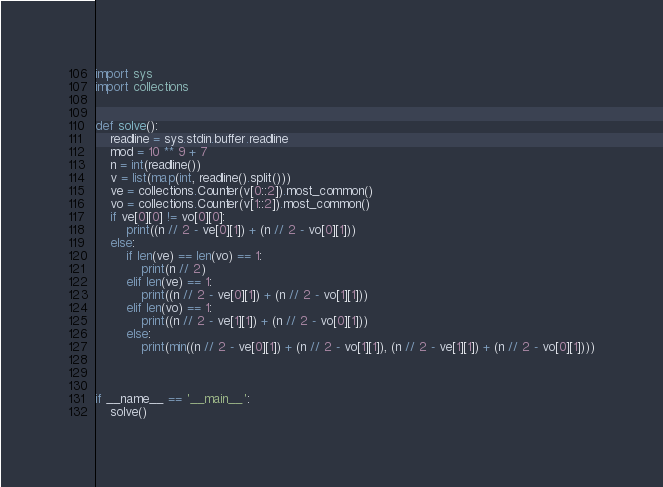<code> <loc_0><loc_0><loc_500><loc_500><_Python_>import sys
import collections


def solve():
    readline = sys.stdin.buffer.readline
    mod = 10 ** 9 + 7
    n = int(readline())
    v = list(map(int, readline().split()))
    ve = collections.Counter(v[0::2]).most_common()
    vo = collections.Counter(v[1::2]).most_common()
    if ve[0][0] != vo[0][0]:
        print((n // 2 - ve[0][1]) + (n // 2 - vo[0][1]))
    else:
        if len(ve) == len(vo) == 1:
            print(n // 2)
        elif len(ve) == 1:
            print((n // 2 - ve[0][1]) + (n // 2 - vo[1][1]))
        elif len(vo) == 1:
            print((n // 2 - ve[1][1]) + (n // 2 - vo[0][1]))
        else:
            print(min((n // 2 - ve[0][1]) + (n // 2 - vo[1][1]), (n // 2 - ve[1][1]) + (n // 2 - vo[0][1])))



if __name__ == '__main__':
    solve()
</code> 